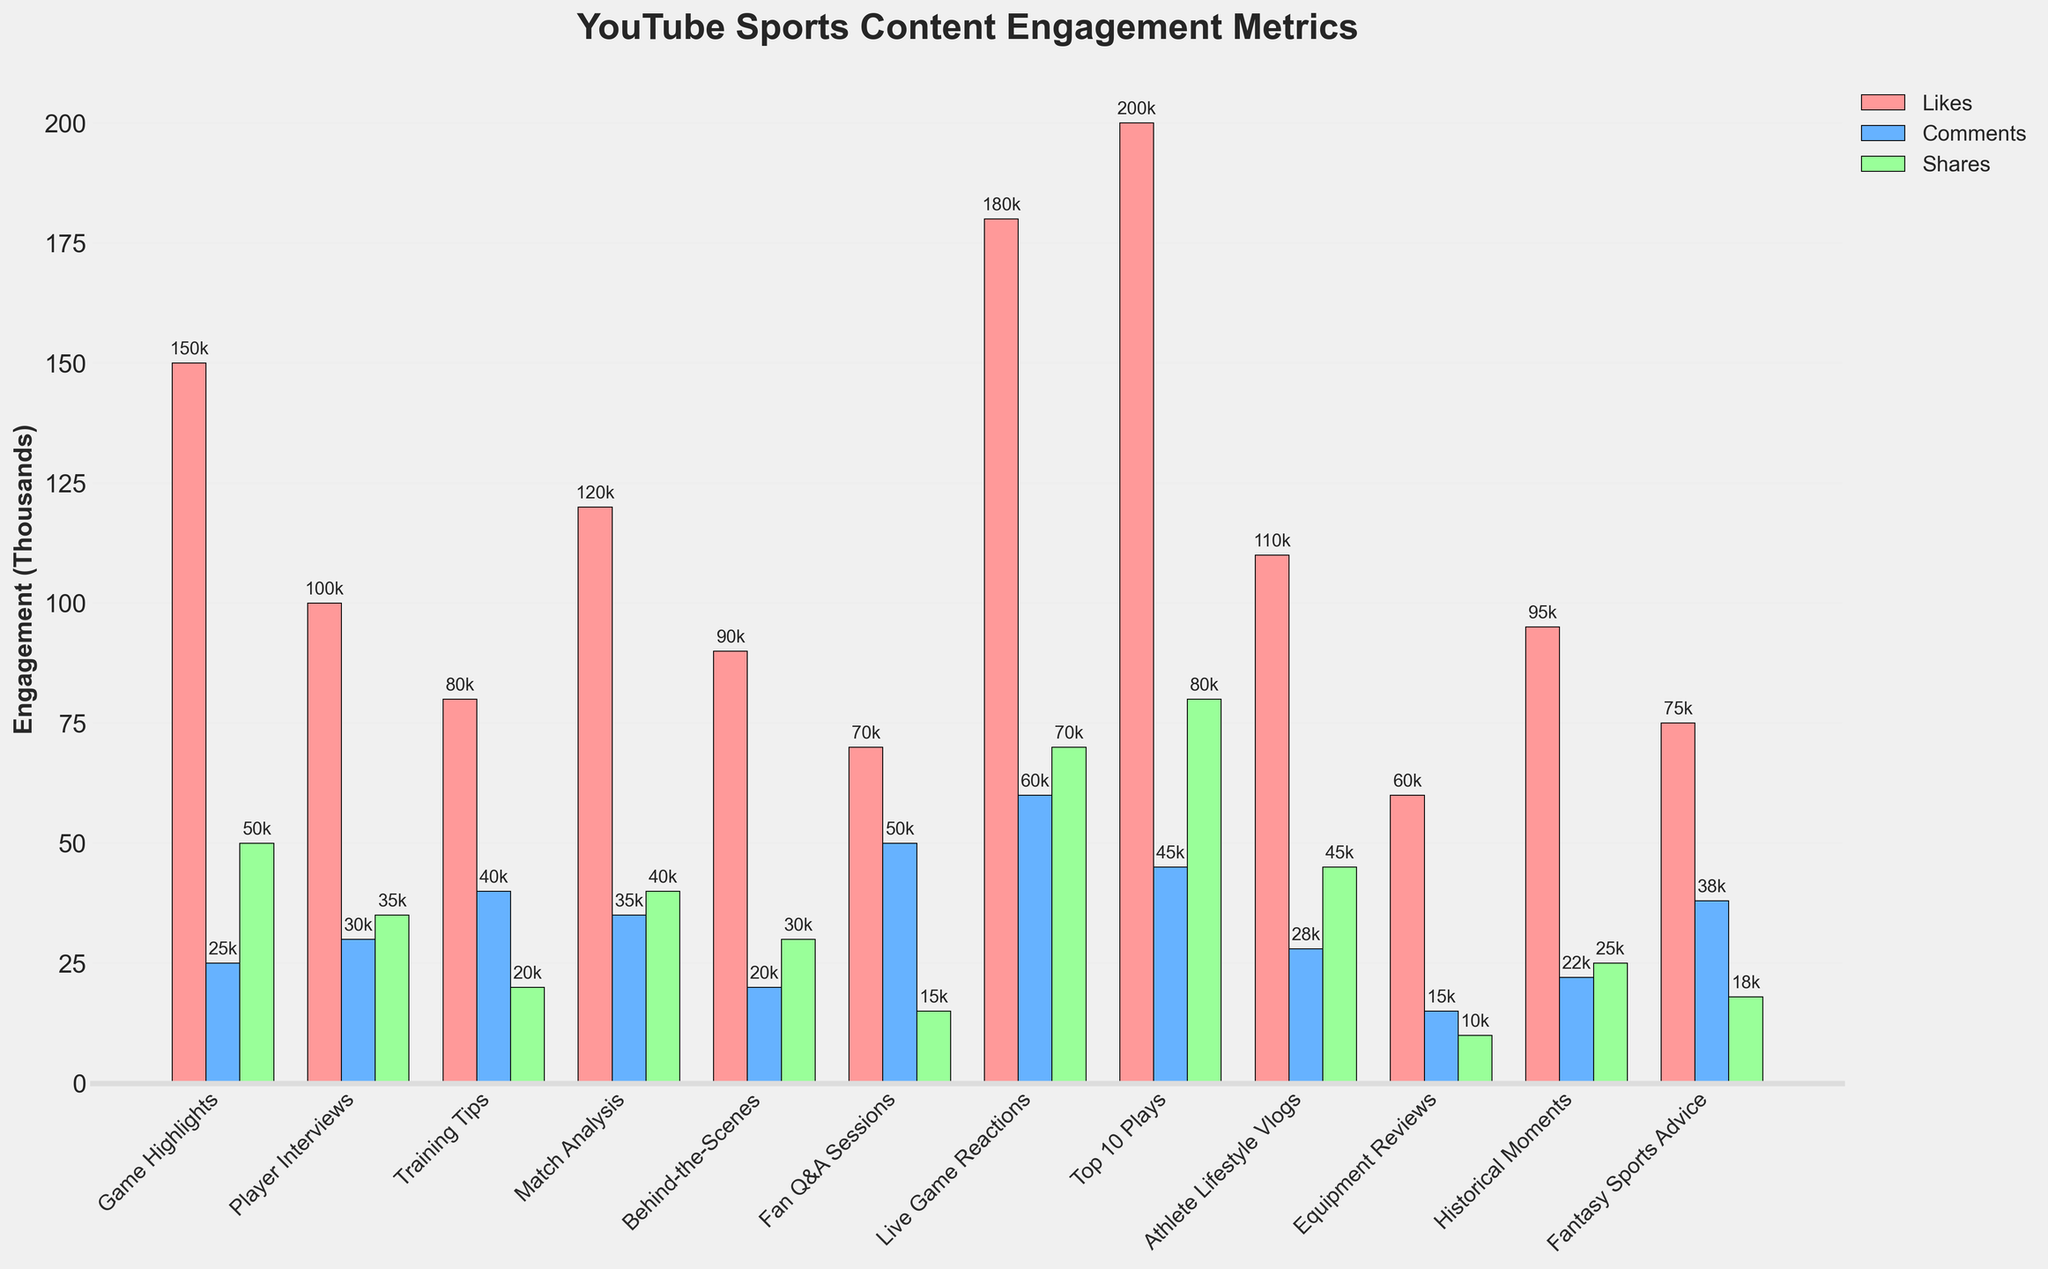What type of content has the highest average number of likes? By looking at the tallest red bar, which represents likes, we can see that 'Top 10 Plays' has the highest bar.
Answer: Top 10 Plays Which content type receives more comments on average, 'Game Highlights' or 'Player Interviews'? By comparing the heights of the blue bars for both content types, we can see that 'Player Interviews' has a taller blue bar than 'Game Highlights'.
Answer: Player Interviews What is the difference in average shares between 'Equipment Reviews' and 'Fan Q&A Sessions'? 'Fan Q&A Sessions' has an average of 15k shares, and 'Equipment Reviews' has 10k shares. The difference is 15k - 10k = 5k.
Answer: 5k Which content type has the most balanced number of likes, comments, and shares? By assessing the bars for each content type and finding which set of bars is most similar in height (balanced), 'Match Analysis' appears to be the most balanced with likes, comments, and shares around 120k, 35k, and 40k respectively.
Answer: Match Analysis On average, how many more comments do 'Live Game Reactions' receive compared to 'Historical Moments'? 'Live Game Reactions' receive an average of 60k comments, while 'Historical Moments' receive 22k comments. The difference is 60k - 22k = 38k.
Answer: 38k If you added the averages of likes and shares for 'Training Tips', what would be the total? 'Training Tips' receive an average of 80k likes and 20k shares. The total is 80k + 20k = 100k.
Answer: 100k Which content type has the least average number of shares? By looking at all the green bars and identifying the shortest one, 'Equipment Reviews' has the shortest green bar.
Answer: Equipment Reviews Is the average number of likes for 'Fan Q&A Sessions' more, less, or equal to the average number of likes for 'Fantasy Sports Advice'? By comparing the heights of the red bars for both content types, 'Fan Q&A Sessions' have 70k likes and 'Fantasy Sports Advice' has 75k, so the former is less.
Answer: Less What is the average number of comments for 'Training Tips' compared to 'Athlete Lifestyle Vlogs' in terms of percentage difference? 'Training Tips' has 40k comments, 'Athlete Lifestyle Vlogs' has 28k comments. The percentage difference is ((40k - 28k) / 40k) * 100 = 30%.
Answer: 30% Which content type gets more engagement (likes + comments + shares) overall, 'Player Interviews' or 'Behind-the-Scenes'? Summing the engagement for each content type: 'Player Interviews' (100k + 30k + 35k = 165k), 'Behind-the-Scenes' (90k + 20k + 30k = 140k). 'Player Interviews' have more engagement.
Answer: Player Interviews 